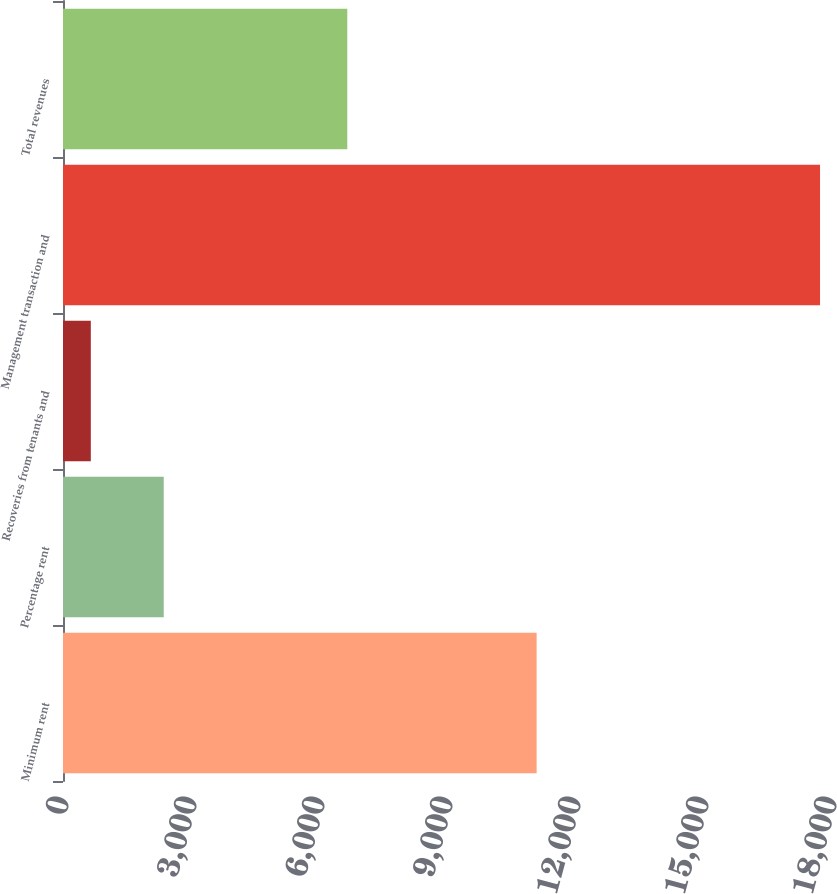Convert chart to OTSL. <chart><loc_0><loc_0><loc_500><loc_500><bar_chart><fcel>Minimum rent<fcel>Percentage rent<fcel>Recoveries from tenants and<fcel>Management transaction and<fcel>Total revenues<nl><fcel>11101<fcel>2361.1<fcel>652<fcel>17743<fcel>6663<nl></chart> 